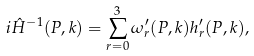<formula> <loc_0><loc_0><loc_500><loc_500>i \hat { H } ^ { - 1 } ( P , k ) = \sum _ { r = 0 } ^ { 3 } \omega _ { r } ^ { \prime } ( P , k ) h _ { r } ^ { \prime } ( P , k ) ,</formula> 